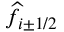Convert formula to latex. <formula><loc_0><loc_0><loc_500><loc_500>\widehat { f } _ { i \pm 1 / 2 }</formula> 